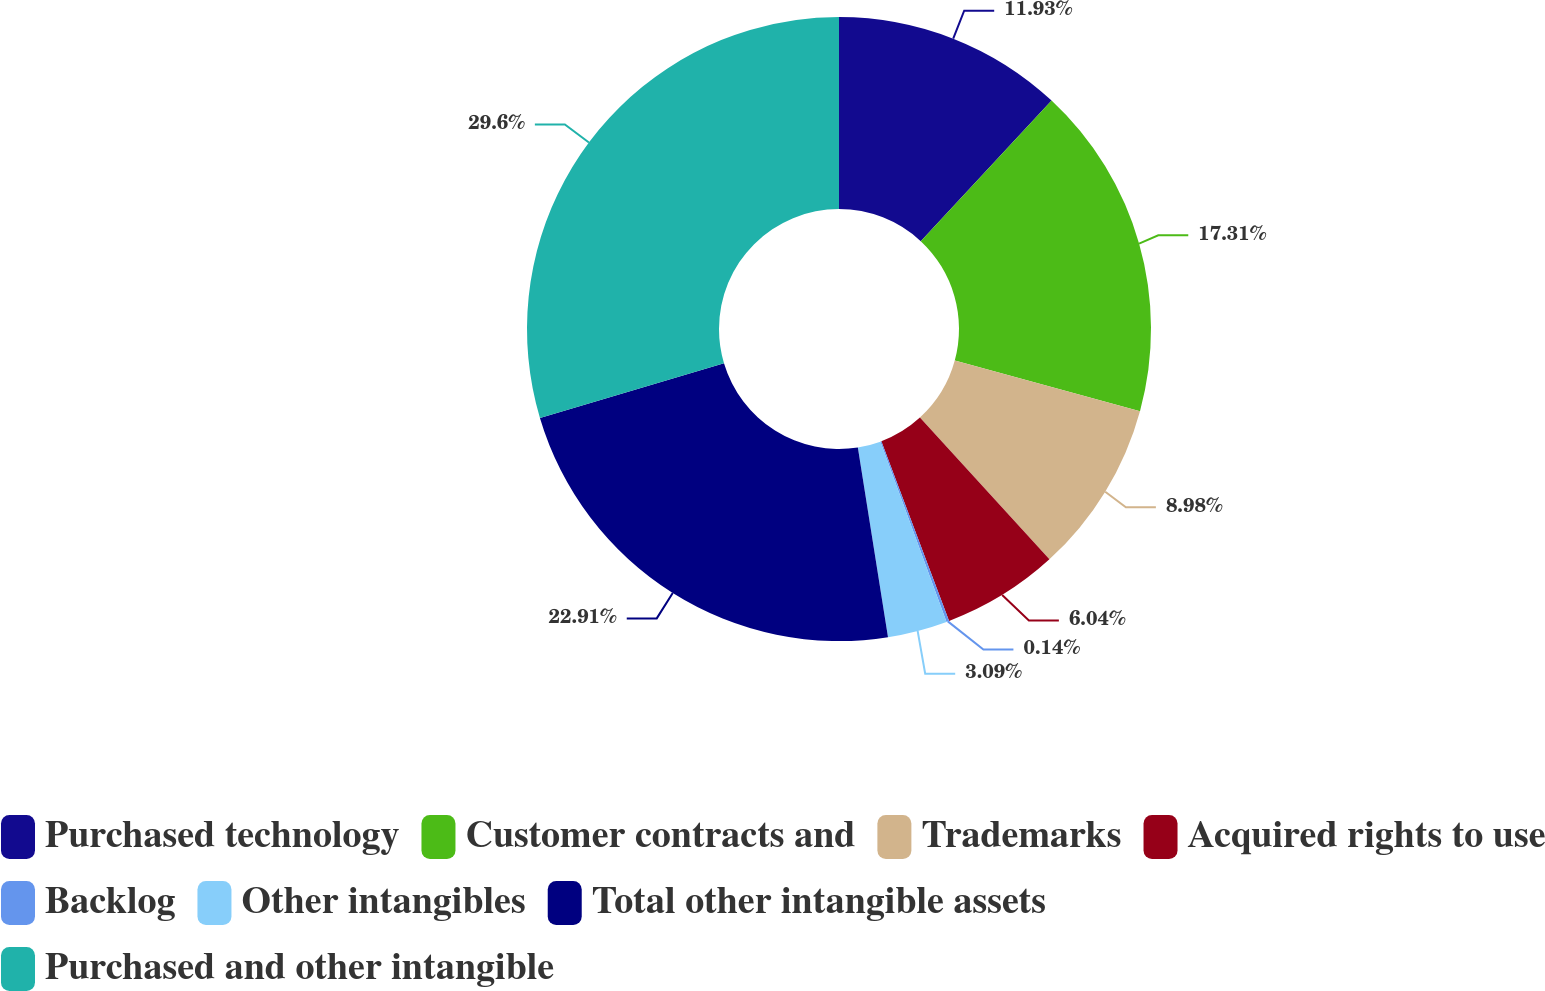<chart> <loc_0><loc_0><loc_500><loc_500><pie_chart><fcel>Purchased technology<fcel>Customer contracts and<fcel>Trademarks<fcel>Acquired rights to use<fcel>Backlog<fcel>Other intangibles<fcel>Total other intangible assets<fcel>Purchased and other intangible<nl><fcel>11.93%<fcel>17.31%<fcel>8.98%<fcel>6.04%<fcel>0.14%<fcel>3.09%<fcel>22.91%<fcel>29.6%<nl></chart> 